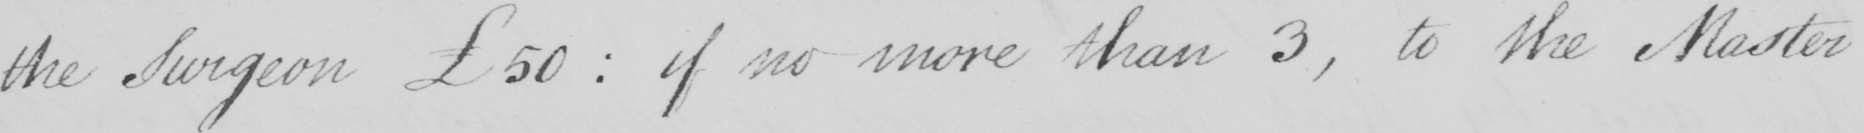Please provide the text content of this handwritten line. the Surgeon £50  :  if no more than 3 , to the Master 